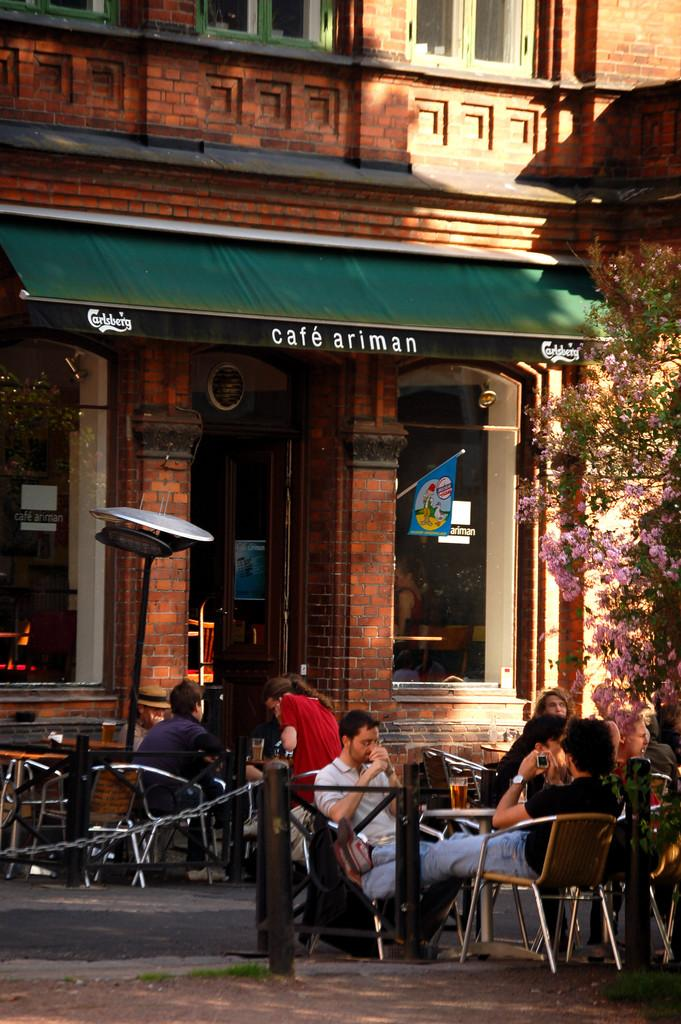What are the people in the image doing? The people in the image are sitting in chairs. Where are the chairs located in relation to the building? The chairs are in front of a building. What can be seen on the left side of the image? There is a tree on the left side of the image. What type of pain is the secretary experiencing in the image? There is no secretary or any indication of pain present in the image. 